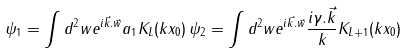Convert formula to latex. <formula><loc_0><loc_0><loc_500><loc_500>\psi _ { 1 } = \int d ^ { 2 } w e ^ { i { \vec { k } . \vec { w } } } a _ { 1 } K _ { L } ( k x _ { 0 } ) \, \psi _ { 2 } = \int d ^ { 2 } w e ^ { i \vec { k } . \vec { w } } \frac { i { \gamma . \vec { k } } } { k } K _ { L + 1 } ( k x _ { 0 } )</formula> 